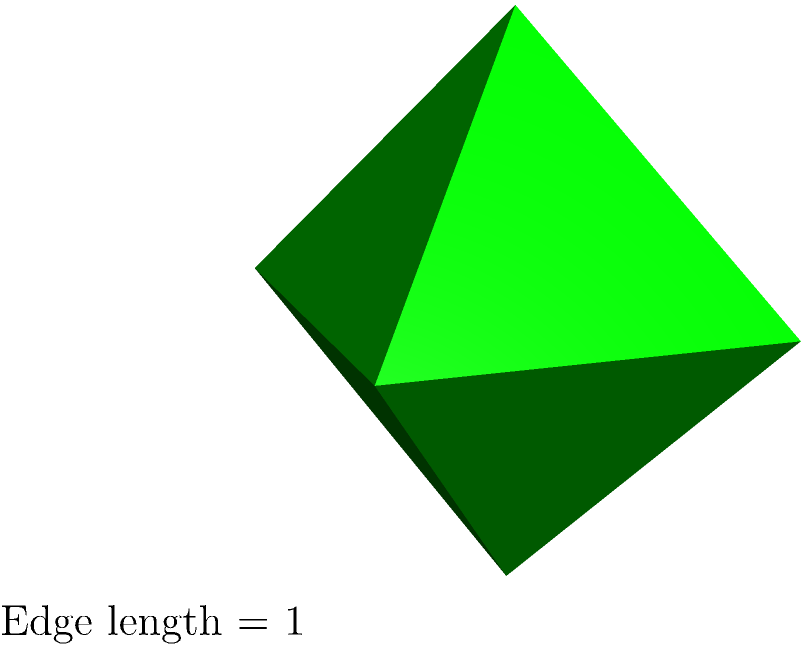SønderjyskE Herrehåndbold has won 1 Danish Handball League title. If we construct a regular octahedron where the edge length is equal to the number of titles won by SønderjyskE, what is the surface area of this octahedron? To find the surface area of a regular octahedron, we can follow these steps:

1) The formula for the surface area of a regular octahedron is:
   $$ A = 2\sqrt{3}a^2 $$
   where $a$ is the edge length.

2) In this case, the edge length $a$ is equal to the number of Danish Handball League titles won by SønderjyskE, which is 1.

3) Let's substitute $a = 1$ into the formula:
   $$ A = 2\sqrt{3}(1)^2 $$

4) Simplify:
   $$ A = 2\sqrt{3} $$

5) This is our final answer. We can leave it in this form as it's an exact value.

Note: The value of $2\sqrt{3}$ is approximately 3.464 square units, but the exact form $2\sqrt{3}$ is preferred in mathematical contexts.
Answer: $2\sqrt{3}$ square units 